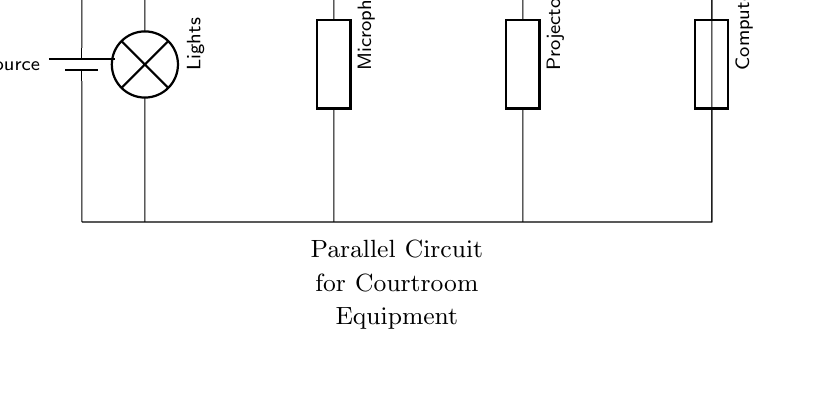What is the power source in the circuit? The circuit diagram shows a battery labeled as the power source, providing the necessary voltage for the connected equipment.
Answer: battery How many distinct loads are connected in parallel? The circuit displays four separate loads: lights, microphones, projector, and computers, all connected in parallel to the power source.
Answer: four What type of circuit is depicted? The circuit is specifically identified as a parallel circuit, where all components share the same voltage source and are connected across common points.
Answer: parallel What is the role of a generic component in the circuit? The generic components represent variable loads such as microphones and projectors, which can change based on courtroom requirements but still receive the same voltage from the power source.
Answer: variable loads If one load fails, what happens to the other loads? In a parallel circuit configuration, if one load fails, the other loads continue to operate normally, as they are connected independently to the power source.
Answer: continue to operate What type of equipment is connected for audio functions? The circuit includes microphones as the audio equipment connected for facilitation of sounds in the courtroom.
Answer: microphones What effect does connecting equipment in parallel have on voltage? In a parallel circuit, all connected equipment experiences the same voltage from the power source, ensuring consistent operation for each piece of equipment.
Answer: same voltage 